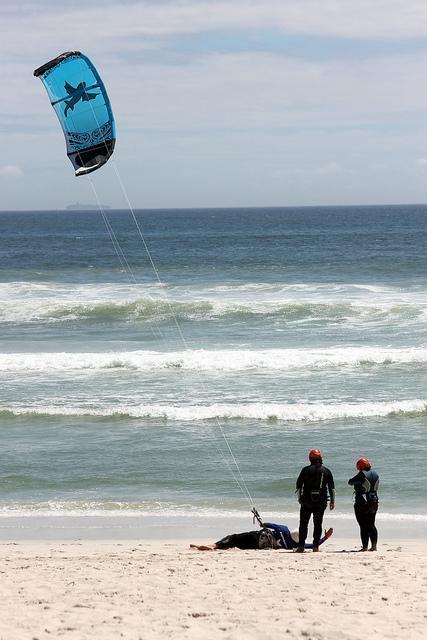How many people are standing up?
Give a very brief answer. 2. How many yellow bikes are there?
Give a very brief answer. 0. 